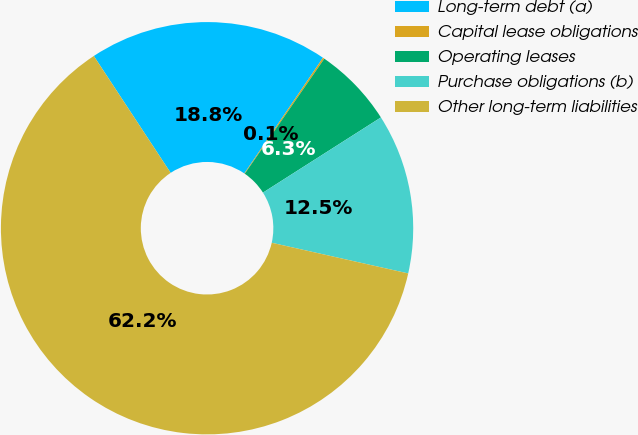Convert chart. <chart><loc_0><loc_0><loc_500><loc_500><pie_chart><fcel>Long-term debt (a)<fcel>Capital lease obligations<fcel>Operating leases<fcel>Purchase obligations (b)<fcel>Other long-term liabilities<nl><fcel>18.76%<fcel>0.13%<fcel>6.34%<fcel>12.55%<fcel>62.23%<nl></chart> 